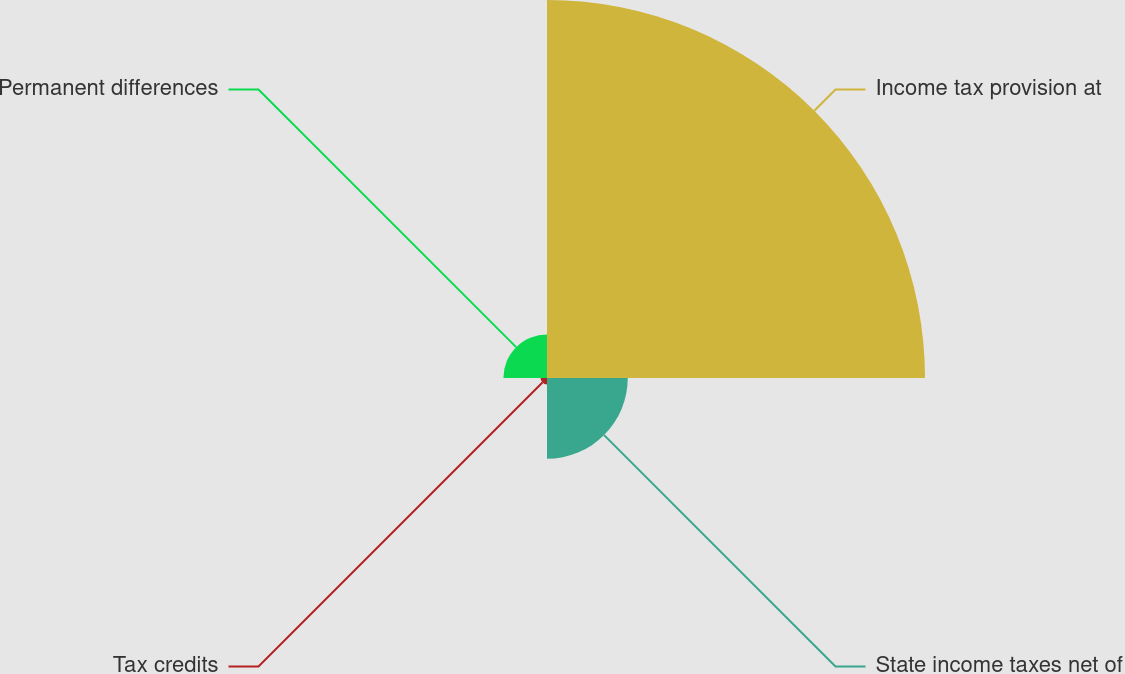Convert chart. <chart><loc_0><loc_0><loc_500><loc_500><pie_chart><fcel>Income tax provision at<fcel>State income taxes net of<fcel>Tax credits<fcel>Permanent differences<nl><fcel>74.28%<fcel>15.87%<fcel>1.27%<fcel>8.57%<nl></chart> 